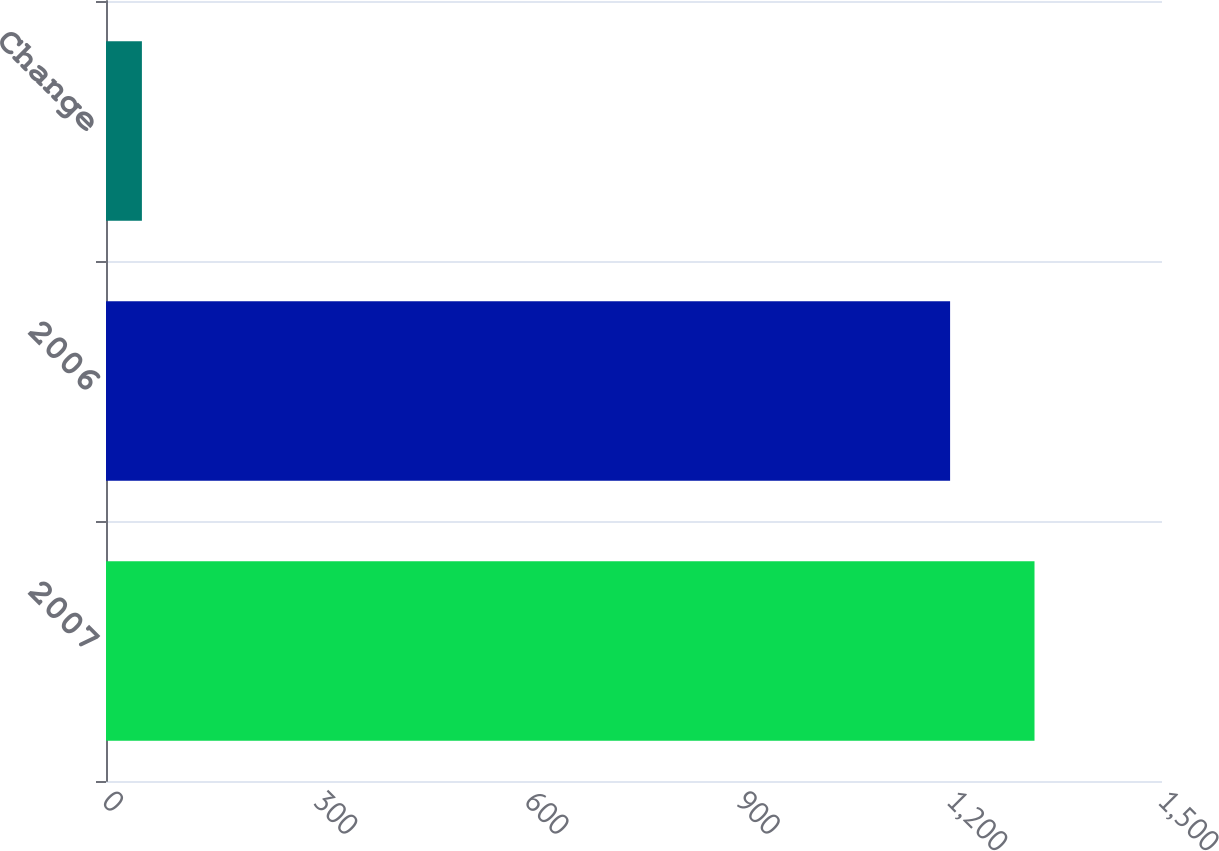<chart> <loc_0><loc_0><loc_500><loc_500><bar_chart><fcel>2007<fcel>2006<fcel>Change<nl><fcel>1318.9<fcel>1199<fcel>51<nl></chart> 